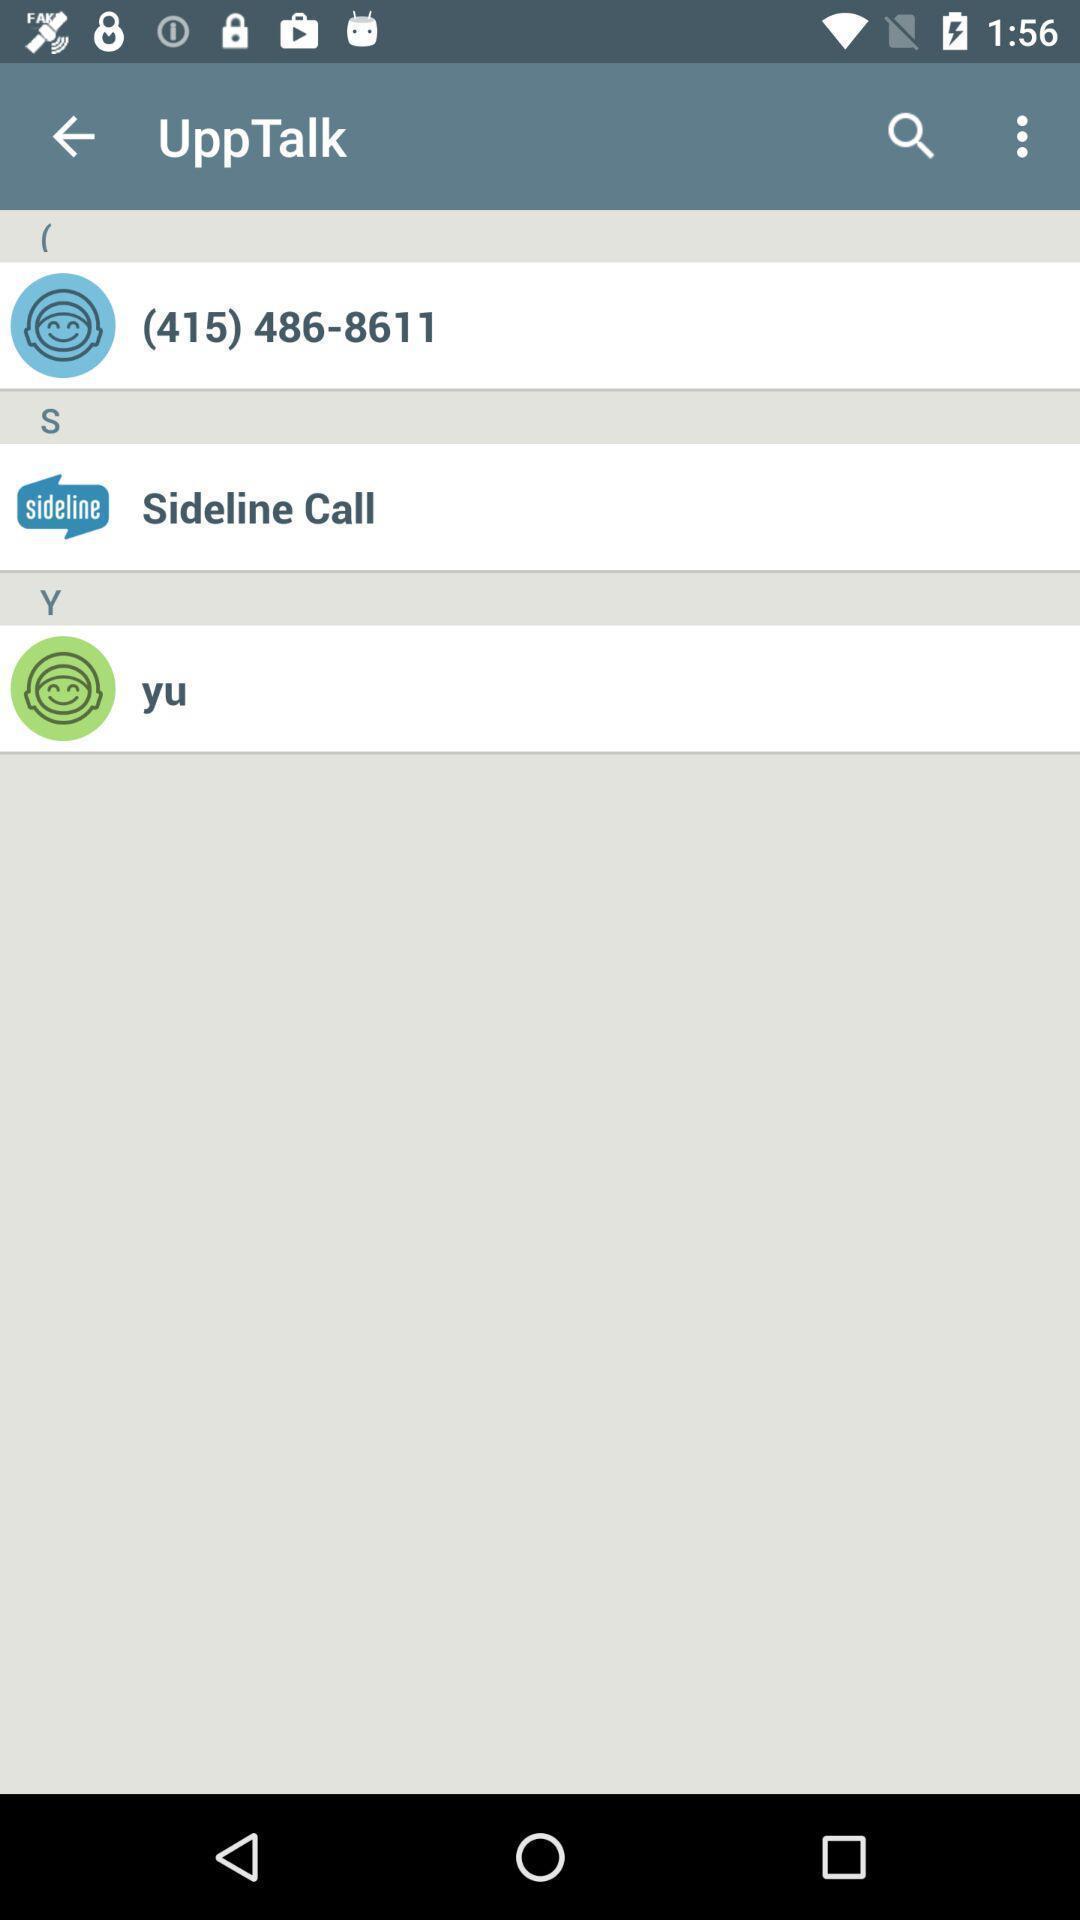Provide a textual representation of this image. Screen showing contacts. 